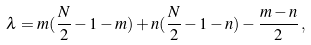Convert formula to latex. <formula><loc_0><loc_0><loc_500><loc_500>\lambda = m ( \frac { N } { 2 } - 1 - m ) + n ( \frac { N } { 2 } - 1 - n ) - \frac { m - n } { 2 } \, ,</formula> 